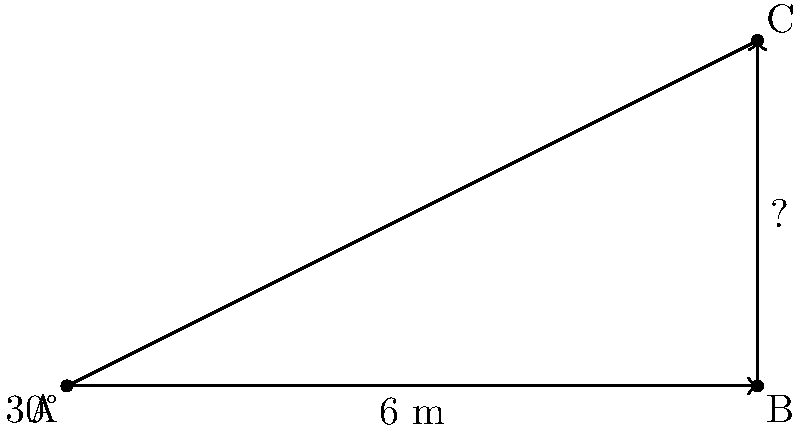As an outraged parent, you decide to measure the height of the new flagpole at Moulsecoomb Primary School to ensure it meets safety standards. Standing 6 meters away from the base of the flagpole, you measure the angle of elevation to the top of the flagpole to be 30°. What is the height of the flagpole? Let's approach this step-by-step:

1) We can use the tangent function to solve this problem. The tangent of an angle in a right triangle is the ratio of the opposite side to the adjacent side.

2) In this case:
   - The angle of elevation is 30°
   - The adjacent side (distance from you to the base of the flagpole) is 6 meters
   - The opposite side (height of the flagpole) is what we're trying to find

3) Let's call the height of the flagpole $h$. We can write the equation:

   $\tan(30°) = \frac{h}{6}$

4) We know that $\tan(30°) = \frac{1}{\sqrt{3}}$, so we can rewrite the equation:

   $\frac{1}{\sqrt{3}} = \frac{h}{6}$

5) To solve for $h$, multiply both sides by 6:

   $\frac{6}{\sqrt{3}} = h$

6) Simplify:

   $h = 2\sqrt{3}$ meters

7) If we want a decimal approximation:

   $h \approx 3.46$ meters

Therefore, the height of the flagpole is $2\sqrt{3}$ meters or approximately 3.46 meters.
Answer: $2\sqrt{3}$ meters 